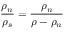Convert formula to latex. <formula><loc_0><loc_0><loc_500><loc_500>\frac { \rho _ { n } } { \rho _ { s } } = \frac { \rho _ { n } } { \rho - \rho _ { n } }</formula> 